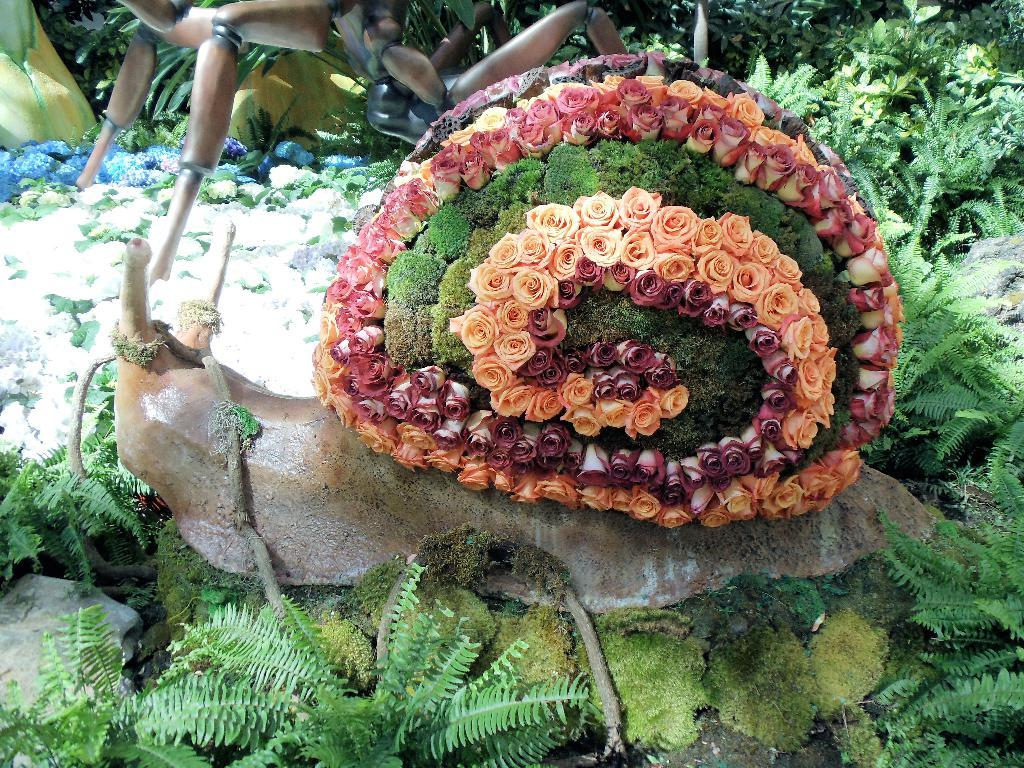What can be seen at the base of the image? The ground is visible in the image. What type of vegetation is present in the image? There are plants and flowers in the image. What other natural elements can be seen in the image? Rocks are visible in the image. Are there any man-made objects in the image? Yes, there are decorative objects in the image. What language is spoken by the flame in the image? There is no flame present in the image, so this question cannot be answered. 